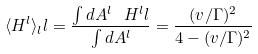Convert formula to latex. <formula><loc_0><loc_0><loc_500><loc_500>\langle H ^ { l } \rangle _ { l } l = \frac { \int d A ^ { l } \ H ^ { l } l } { \int d A ^ { l } } = \frac { ( v / \Gamma ) ^ { 2 } } { 4 - ( v / \Gamma ) ^ { 2 } }</formula> 